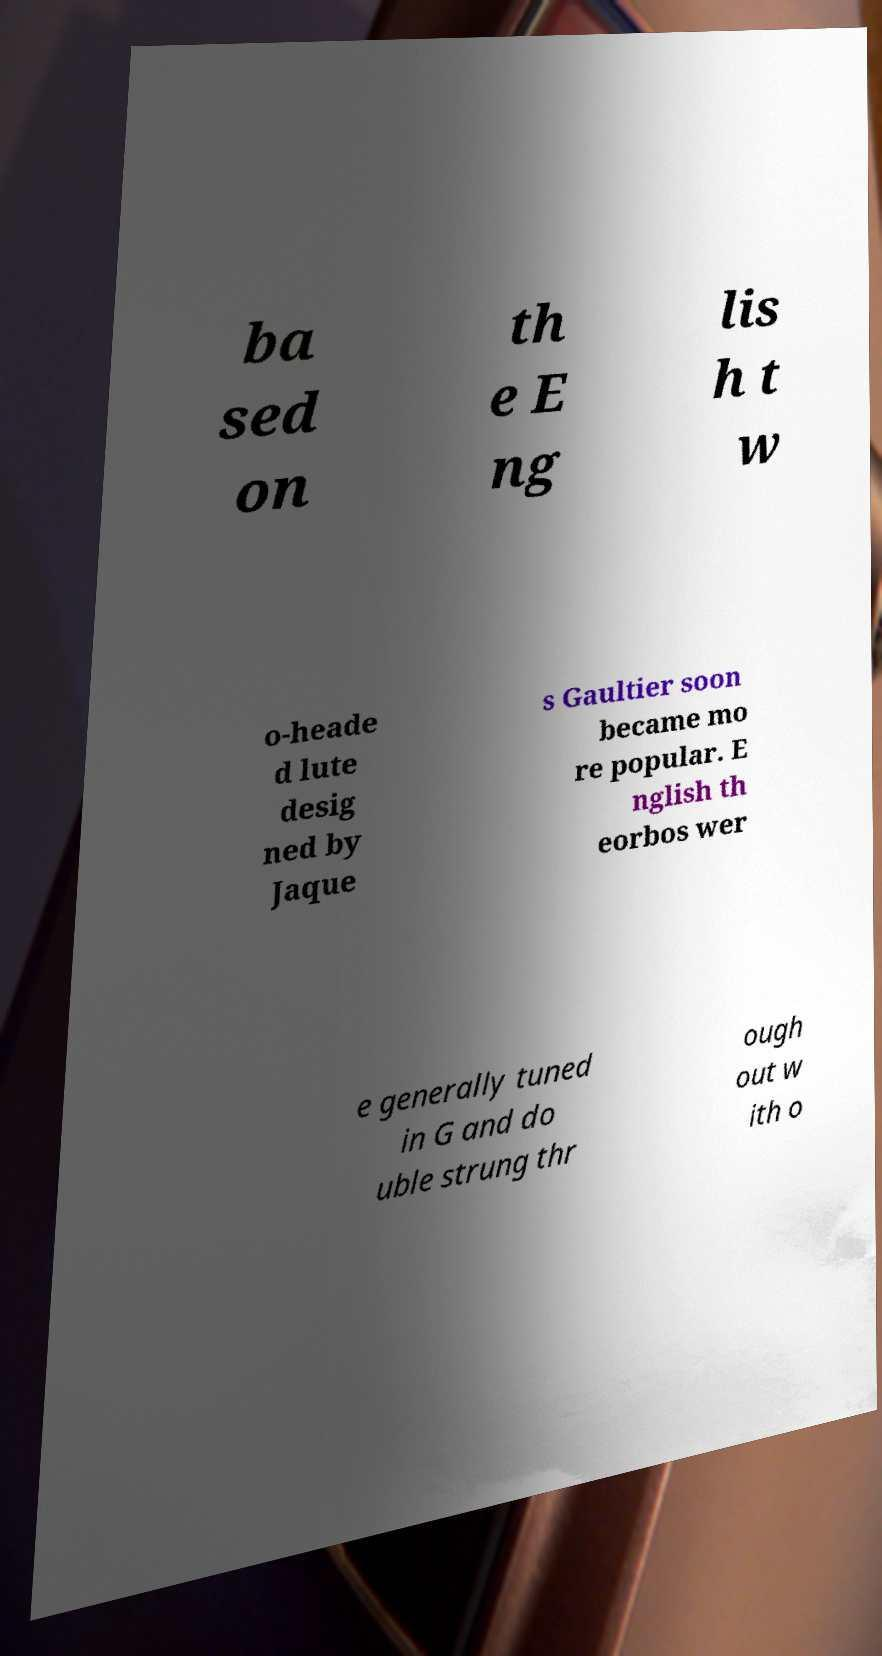There's text embedded in this image that I need extracted. Can you transcribe it verbatim? ba sed on th e E ng lis h t w o-heade d lute desig ned by Jaque s Gaultier soon became mo re popular. E nglish th eorbos wer e generally tuned in G and do uble strung thr ough out w ith o 